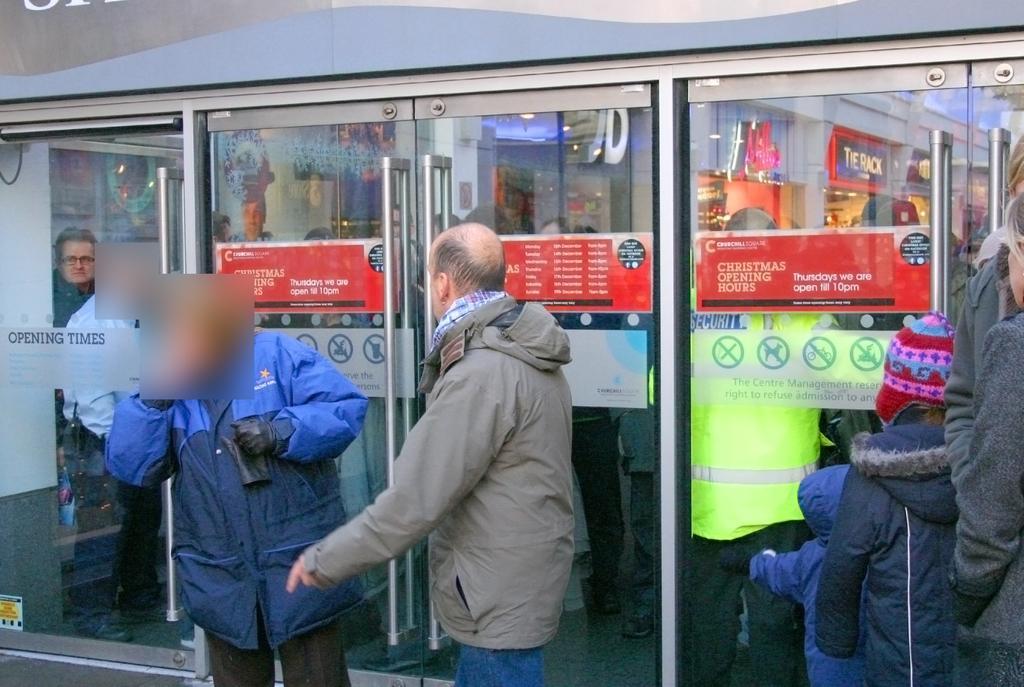Describe this image in one or two sentences. In this picture I can observe some people standing in front of a store. I can observe some posters on the glass doors in the background. 